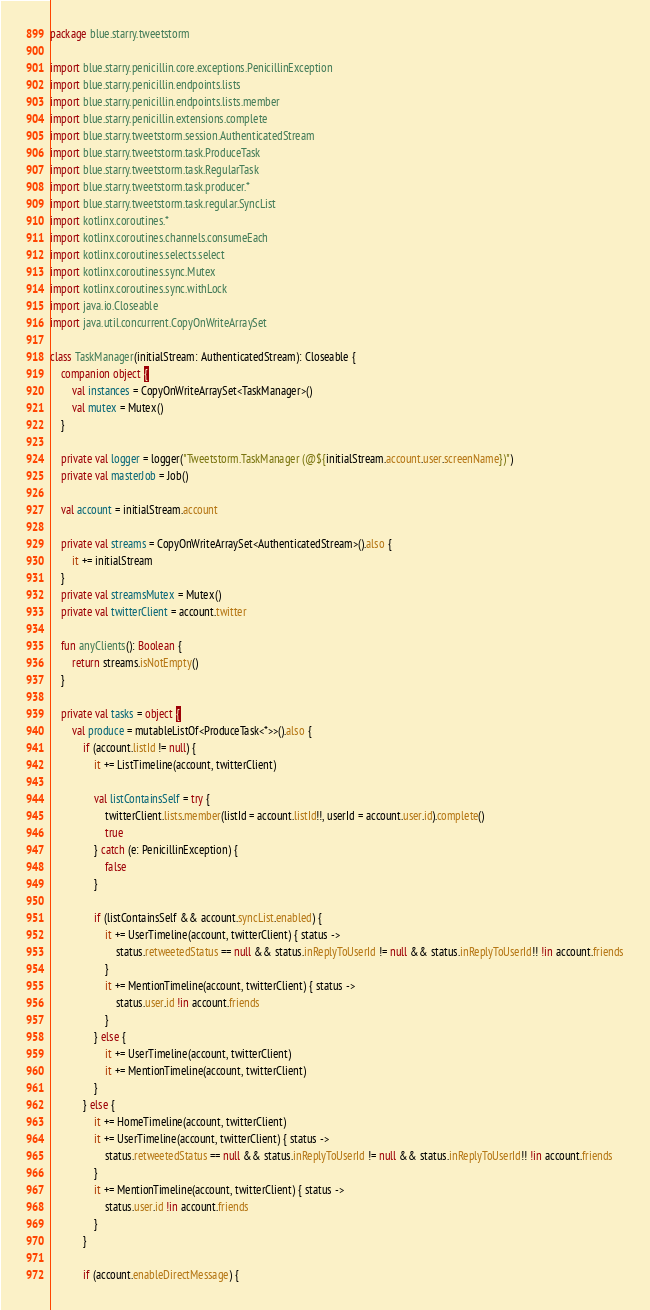Convert code to text. <code><loc_0><loc_0><loc_500><loc_500><_Kotlin_>package blue.starry.tweetstorm

import blue.starry.penicillin.core.exceptions.PenicillinException
import blue.starry.penicillin.endpoints.lists
import blue.starry.penicillin.endpoints.lists.member
import blue.starry.penicillin.extensions.complete
import blue.starry.tweetstorm.session.AuthenticatedStream
import blue.starry.tweetstorm.task.ProduceTask
import blue.starry.tweetstorm.task.RegularTask
import blue.starry.tweetstorm.task.producer.*
import blue.starry.tweetstorm.task.regular.SyncList
import kotlinx.coroutines.*
import kotlinx.coroutines.channels.consumeEach
import kotlinx.coroutines.selects.select
import kotlinx.coroutines.sync.Mutex
import kotlinx.coroutines.sync.withLock
import java.io.Closeable
import java.util.concurrent.CopyOnWriteArraySet

class TaskManager(initialStream: AuthenticatedStream): Closeable {
    companion object {
        val instances = CopyOnWriteArraySet<TaskManager>()
        val mutex = Mutex()
    }

    private val logger = logger("Tweetstorm.TaskManager (@${initialStream.account.user.screenName})")
    private val masterJob = Job()

    val account = initialStream.account

    private val streams = CopyOnWriteArraySet<AuthenticatedStream>().also {
        it += initialStream
    }
    private val streamsMutex = Mutex()
    private val twitterClient = account.twitter

    fun anyClients(): Boolean {
        return streams.isNotEmpty()
    }

    private val tasks = object {
        val produce = mutableListOf<ProduceTask<*>>().also {
            if (account.listId != null) {
                it += ListTimeline(account, twitterClient)

                val listContainsSelf = try {
                    twitterClient.lists.member(listId = account.listId!!, userId = account.user.id).complete()
                    true
                } catch (e: PenicillinException) {
                    false
                }

                if (listContainsSelf && account.syncList.enabled) {
                    it += UserTimeline(account, twitterClient) { status ->
                        status.retweetedStatus == null && status.inReplyToUserId != null && status.inReplyToUserId!! !in account.friends
                    }
                    it += MentionTimeline(account, twitterClient) { status ->
                        status.user.id !in account.friends
                    }
                } else {
                    it += UserTimeline(account, twitterClient)
                    it += MentionTimeline(account, twitterClient)
                }
            } else {
                it += HomeTimeline(account, twitterClient)
                it += UserTimeline(account, twitterClient) { status ->
                    status.retweetedStatus == null && status.inReplyToUserId != null && status.inReplyToUserId!! !in account.friends
                }
                it += MentionTimeline(account, twitterClient) { status ->
                    status.user.id !in account.friends
                }
            }

            if (account.enableDirectMessage) {</code> 